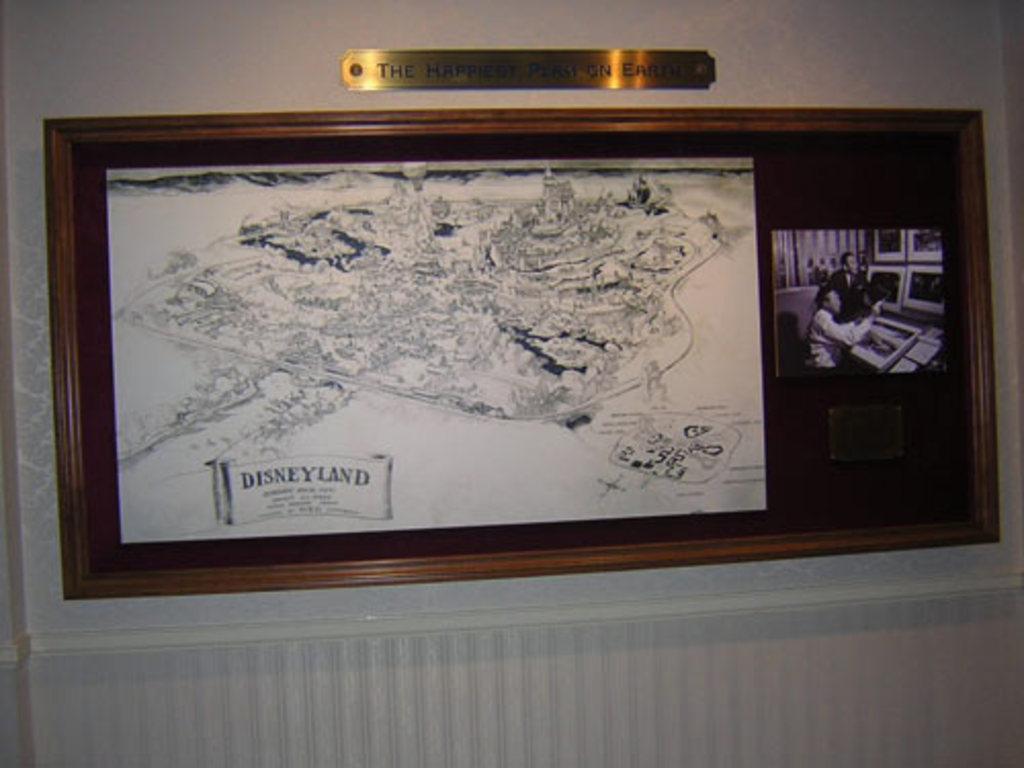Please provide a concise description of this image. In this image there is a board on the wall. On the board there is a map with text and a photograph. On top of the board there is a nameplate. 